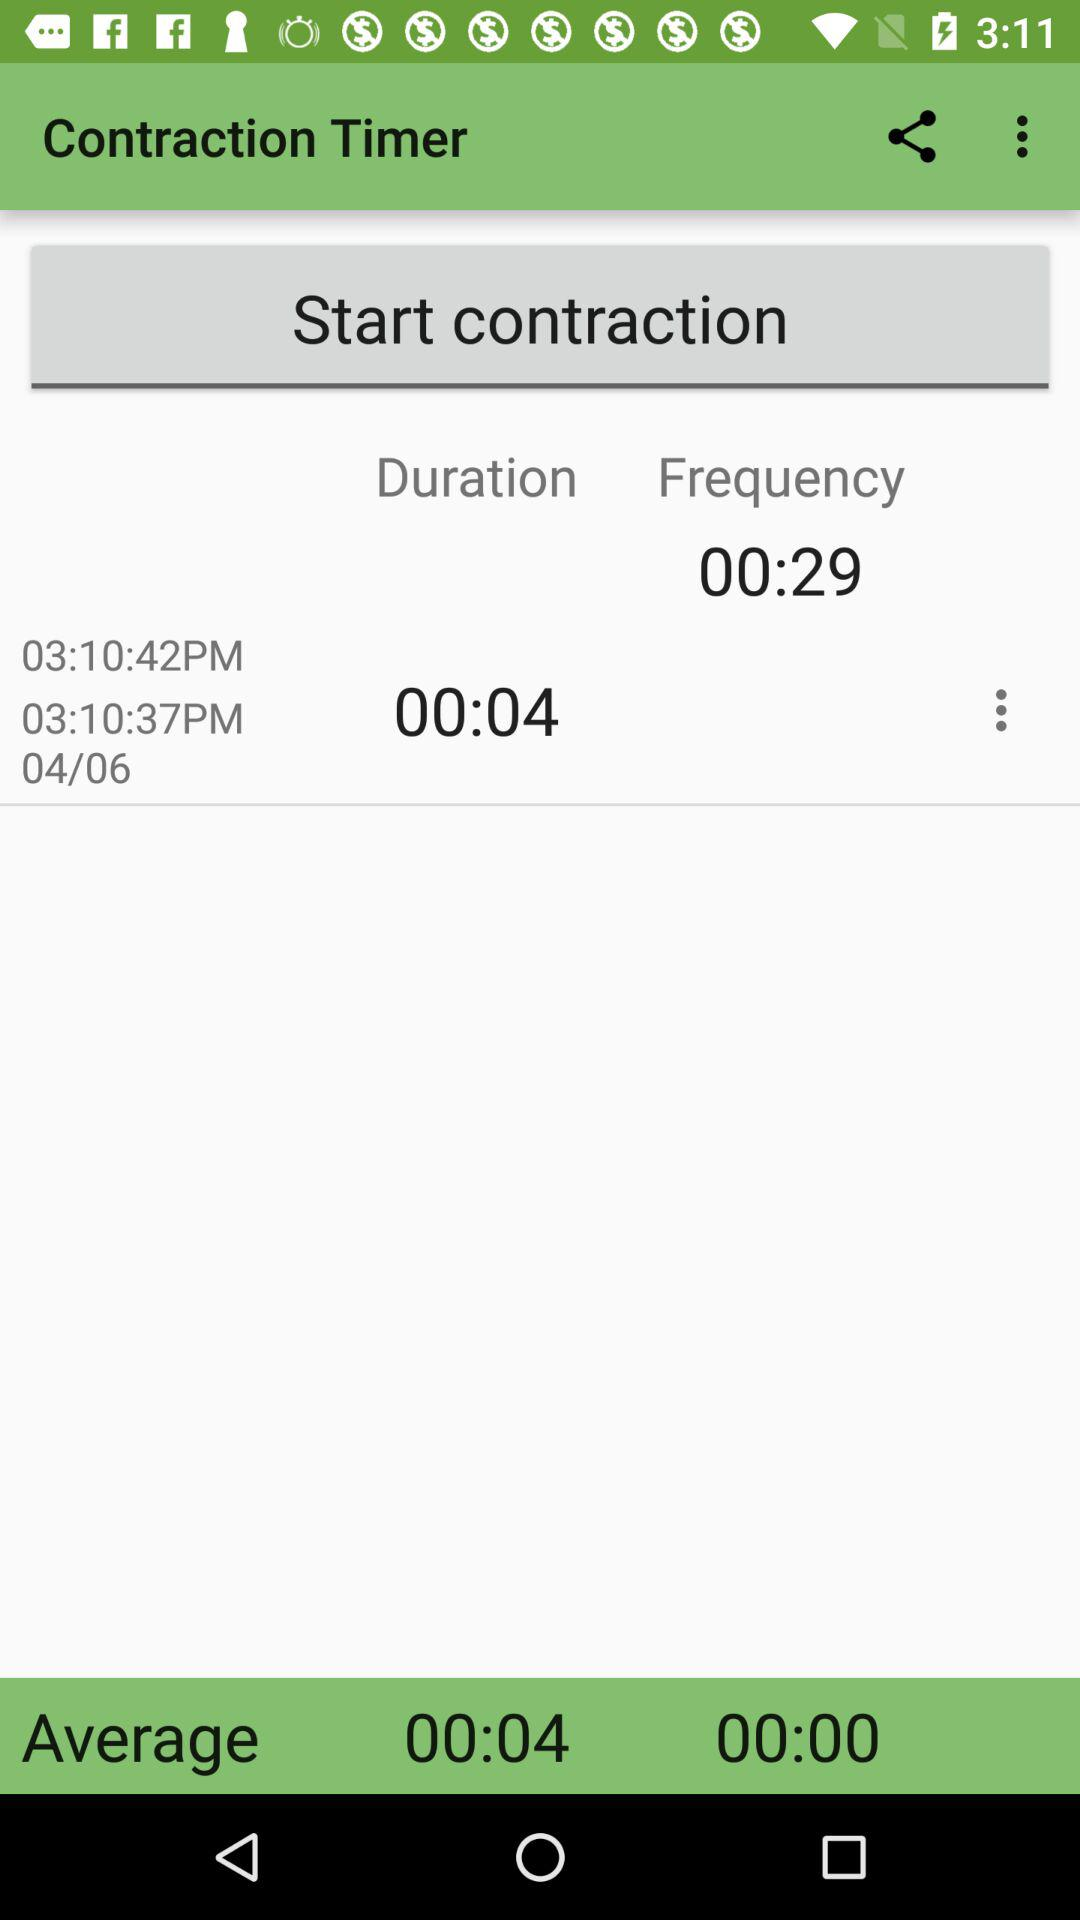At which duration is the frequency set?
When the provided information is insufficient, respond with <no answer>. <no answer> 